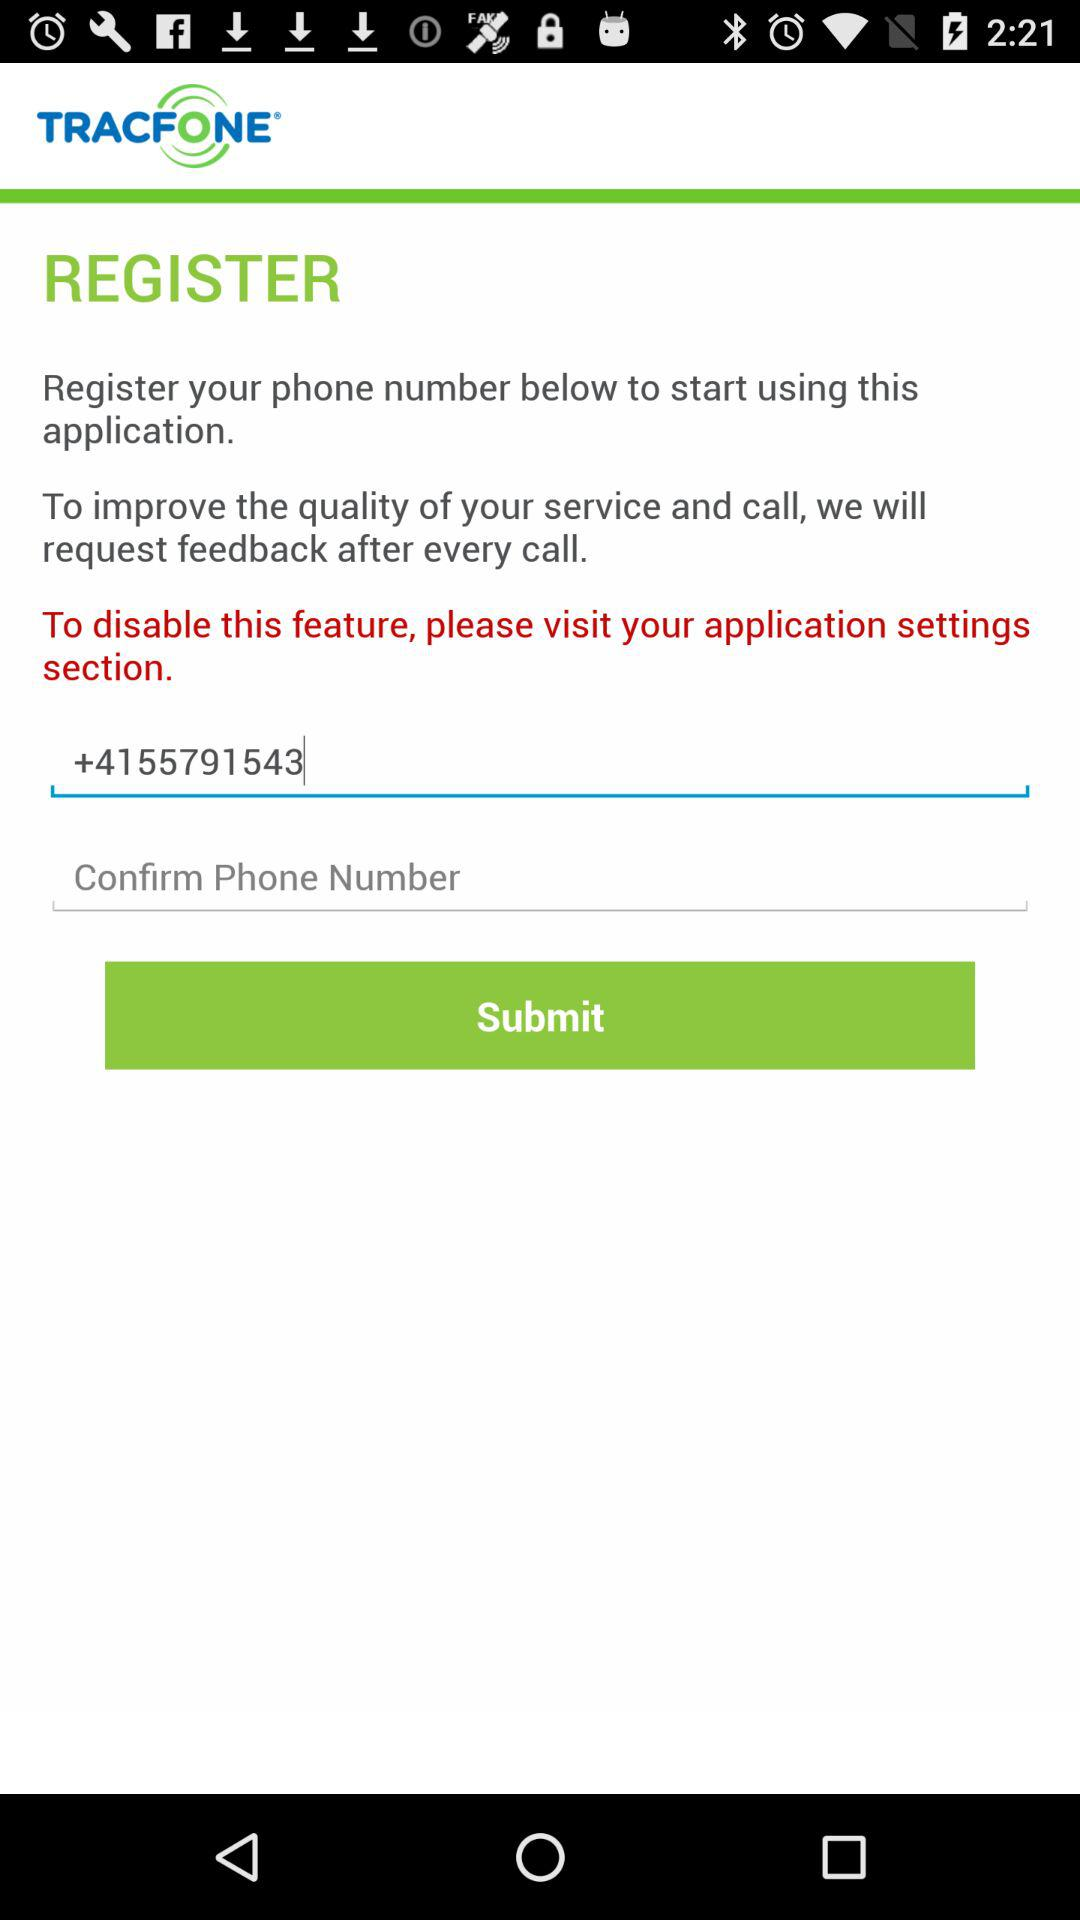What is the entered phone number? The entered phone number is +4155791543. 